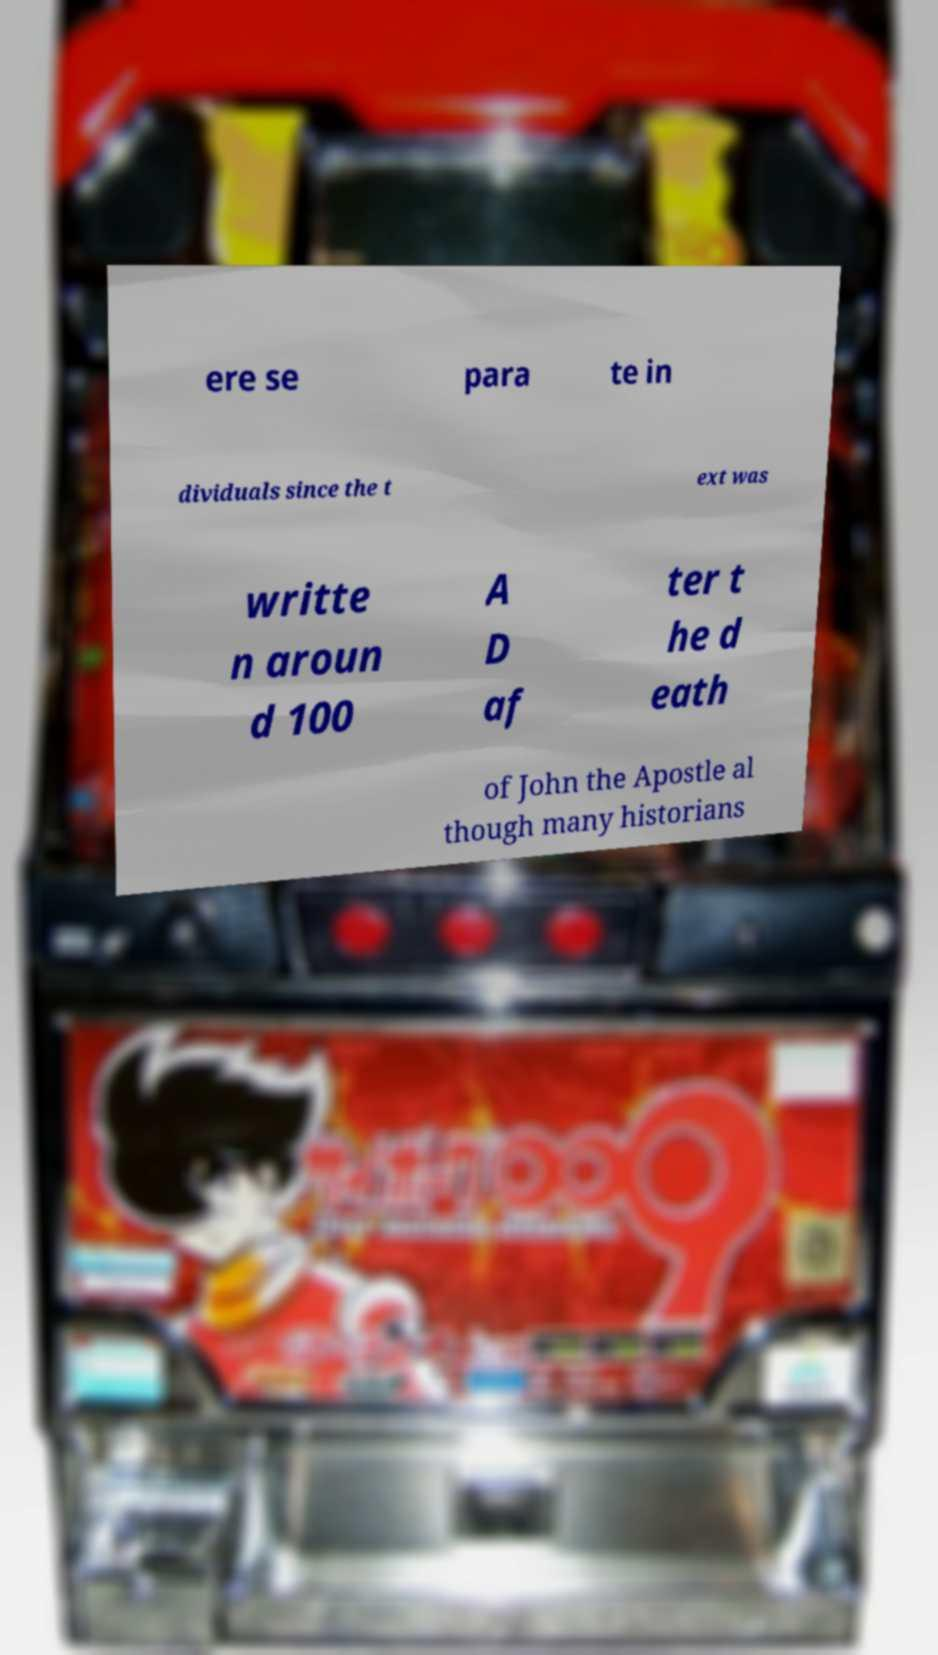Could you assist in decoding the text presented in this image and type it out clearly? ere se para te in dividuals since the t ext was writte n aroun d 100 A D af ter t he d eath of John the Apostle al though many historians 